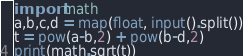<code> <loc_0><loc_0><loc_500><loc_500><_Python_>import math
a,b,c,d = map(float, input().split())
t = pow(a-b,2) + pow(b-d,2)
print(math.sqrt(t))</code> 